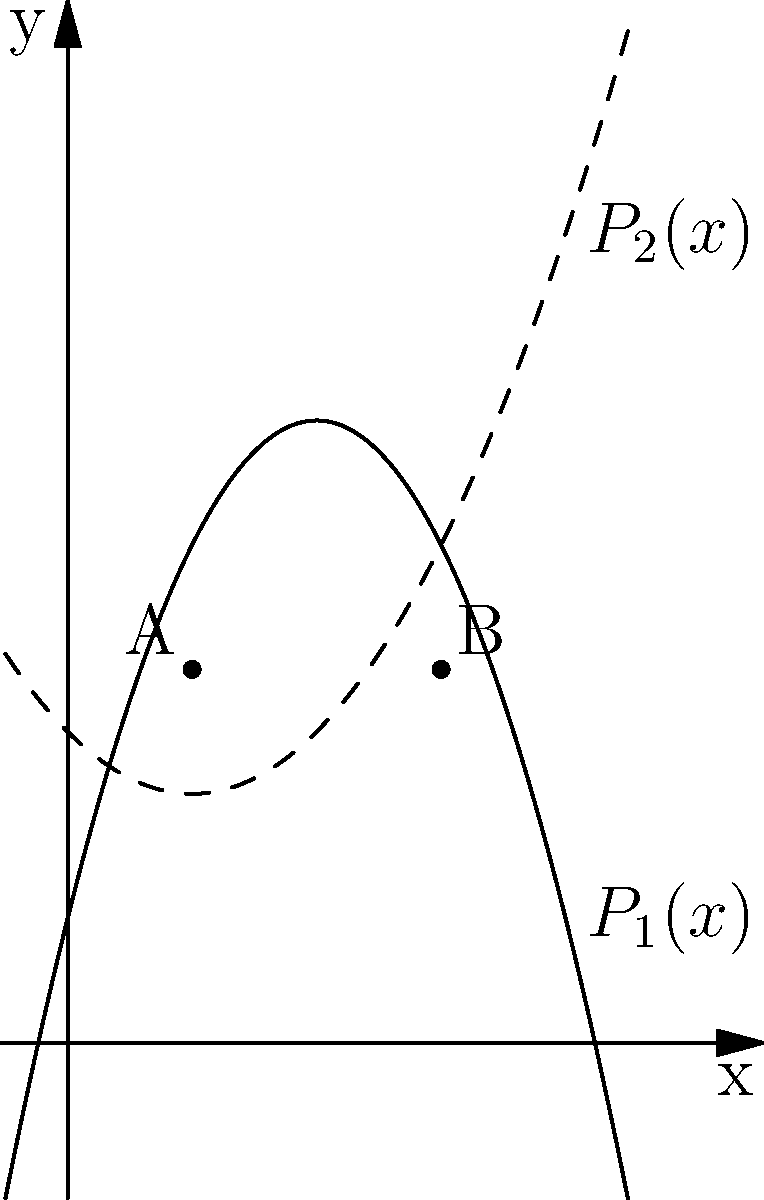Two competing microfinance programs in Southeast Asia have profit functions represented by the parabolas $P_1(x) = -0.5x^2 + 4x + 2$ and $P_2(x) = 0.25x^2 - x + 5$, where $x$ is the number of loans (in thousands) and $P$ is the profit (in million dollars). At what number of loans do these programs have equal profits, and what is the profit at this point? To find the point(s) of intersection, we need to solve the equation:

$$P_1(x) = P_2(x)$$

$$-0.5x^2 + 4x + 2 = 0.25x^2 - x + 5$$

Rearranging the terms:

$$-0.75x^2 + 5x - 3 = 0$$

Multiply all terms by -4/3 to simplify:

$$x^2 - \frac{20}{3}x + 4 = 0$$

This is a quadratic equation. We can solve it using the quadratic formula:

$$x = \frac{-b \pm \sqrt{b^2 - 4ac}}{2a}$$

Where $a=1$, $b=-\frac{20}{3}$, and $c=4$

$$x = \frac{\frac{20}{3} \pm \sqrt{(\frac{20}{3})^2 - 4(1)(4)}}{2(1)}$$

$$x = \frac{\frac{20}{3} \pm \sqrt{\frac{400}{9} - 16}}{2}$$

$$x = \frac{\frac{20}{3} \pm \sqrt{\frac{256}{9}}}{2}$$

$$x = \frac{\frac{20}{3} \pm \frac{16}{3}}{2}$$

This gives us two solutions:

$$x = \frac{\frac{20}{3} + \frac{16}{3}}{2} = 6$$
$$x = \frac{\frac{20}{3} - \frac{16}{3}}{2} = 2$$

To find the profit at these points, we can substitute either x value into either profit function:

$$P_1(2) = -0.5(2)^2 + 4(2) + 2 = 6$$
$$P_1(6) = -0.5(6)^2 + 4(6) + 2 = 6$$

Therefore, the programs have equal profits when they issue 2,000 or 6,000 loans, and the profit at these points is $6 million.
Answer: 2,000 or 6,000 loans; $6 million profit 